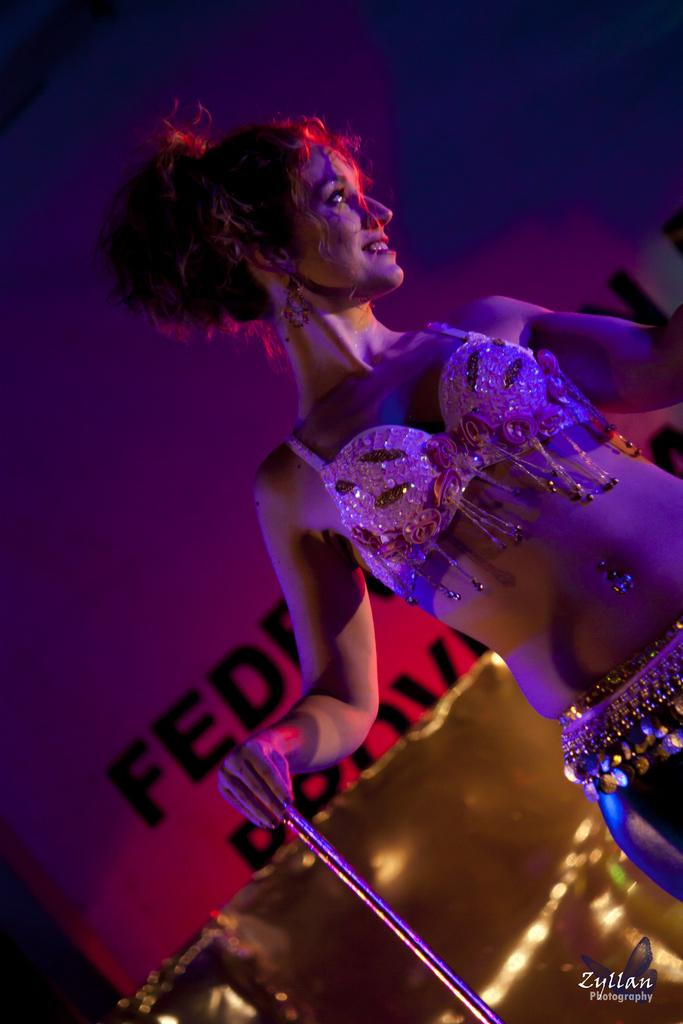What is the main subject of the image? There is a woman standing in the image. What is the woman holding in the image? The woman is holding a stick. What can be seen in the background of the image? There is a banner in the background of the image. How many rings can be seen on the woman's fingers in the image? There is no mention of rings in the provided facts, and therefore we cannot determine the number of rings on the woman's fingers. Is the woman holding a gun in the image? No, the woman is holding a stick, not a gun, as stated in the provided facts. 